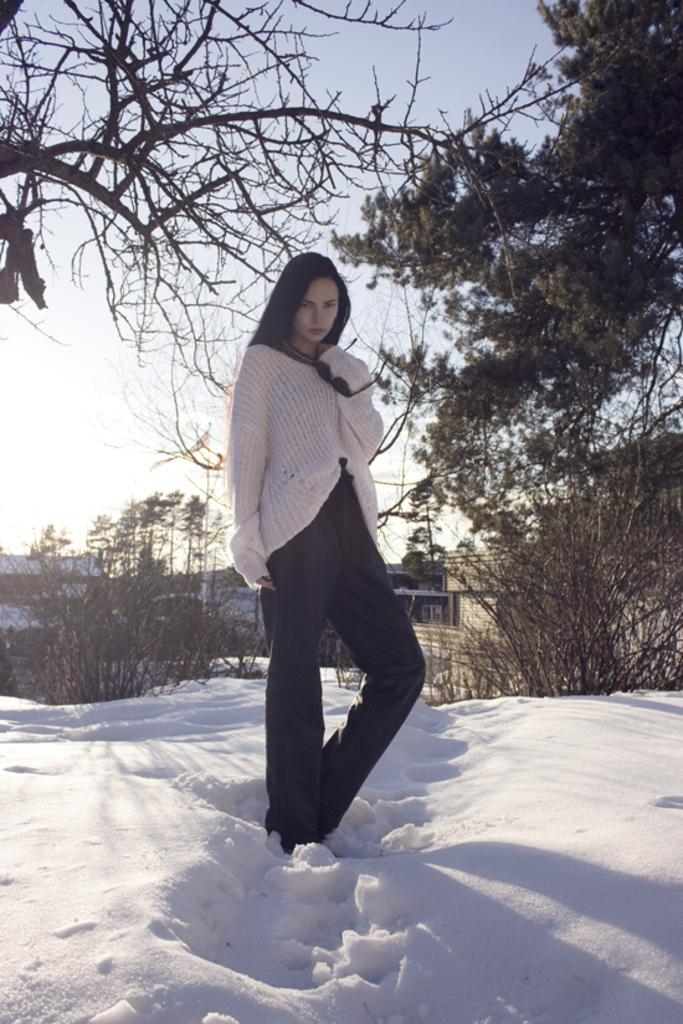Who is present in the image? There is a woman in the image. What is the woman standing on? The woman is standing on snow. What can be seen in the background of the image? There are planets, houses, trees, and the sky visible in the background of the image. What tools is the carpenter using to build a table in the image? There is no carpenter or table-building activity present in the image. 